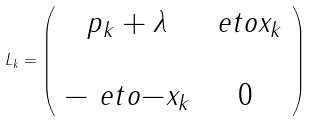Convert formula to latex. <formula><loc_0><loc_0><loc_500><loc_500>L _ { k } = \left ( \begin{array} { c c } p _ { k } + \lambda & \ e t o { x _ { k } } \\ \\ - \ e t o { - x _ { k } } & 0 \end{array} \right )</formula> 